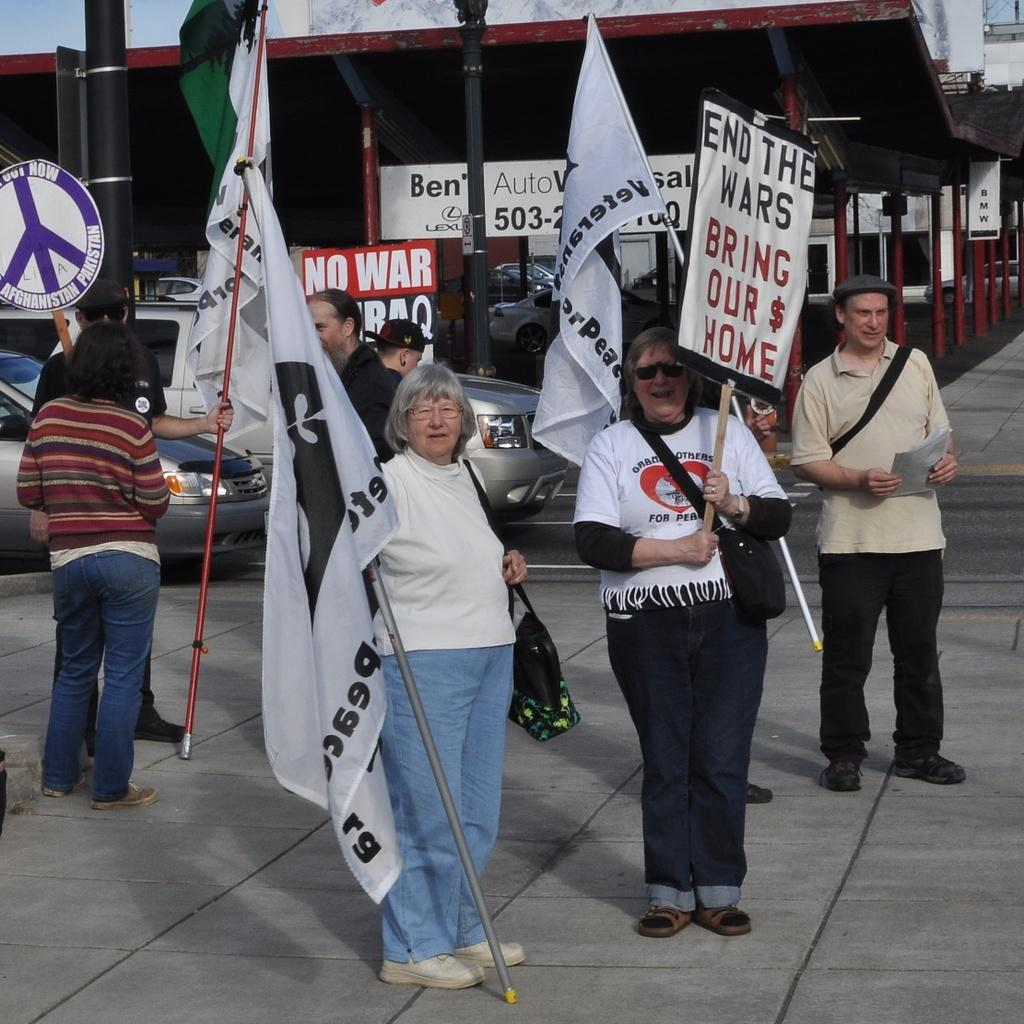What are the people on the walkway doing in the image? The people standing on the walkway are holding flags. What else can be seen in the image besides the people holding flags? There is a banner visible, as well as cars on the left side of the image. What is located in the background of the image? There is a parking lot in the background of the image. Can you describe the waves crashing on the shore in the image? There are no waves or shore visible in the image; it features people holding flags, a banner, cars, and a parking lot. 